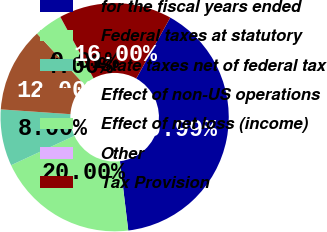Convert chart to OTSL. <chart><loc_0><loc_0><loc_500><loc_500><pie_chart><fcel>for the fiscal years ended<fcel>Federal taxes at statutory<fcel>State taxes net of federal tax<fcel>Effect of non-US operations<fcel>Effect of net loss (income)<fcel>Other<fcel>Tax Provision<nl><fcel>39.99%<fcel>20.0%<fcel>8.0%<fcel>12.0%<fcel>4.0%<fcel>0.01%<fcel>16.0%<nl></chart> 